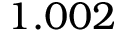Convert formula to latex. <formula><loc_0><loc_0><loc_500><loc_500>1 . 0 0 2</formula> 